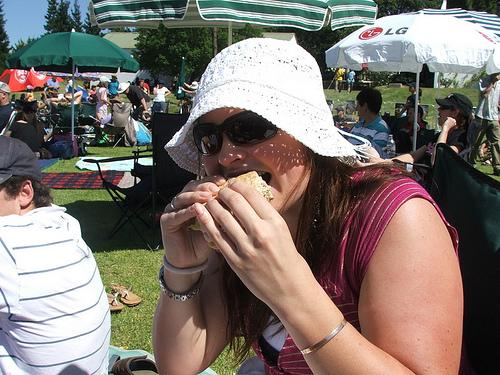What is the woman doing with the object in her hand? Please explain your reasoning. eating it. The woman is eating. 